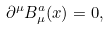Convert formula to latex. <formula><loc_0><loc_0><loc_500><loc_500>\partial ^ { \mu } B ^ { a } _ { \mu } ( x ) = 0 ,</formula> 